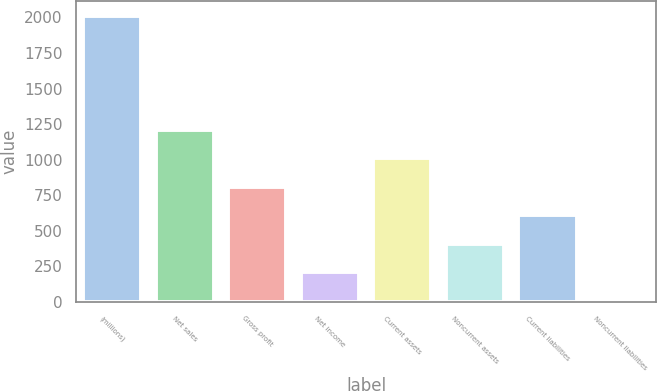<chart> <loc_0><loc_0><loc_500><loc_500><bar_chart><fcel>(millions)<fcel>Net sales<fcel>Gross profit<fcel>Net income<fcel>Current assets<fcel>Noncurrent assets<fcel>Current liabilities<fcel>Noncurrent liabilities<nl><fcel>2013<fcel>1210.68<fcel>809.52<fcel>207.78<fcel>1010.1<fcel>408.36<fcel>608.94<fcel>7.2<nl></chart> 